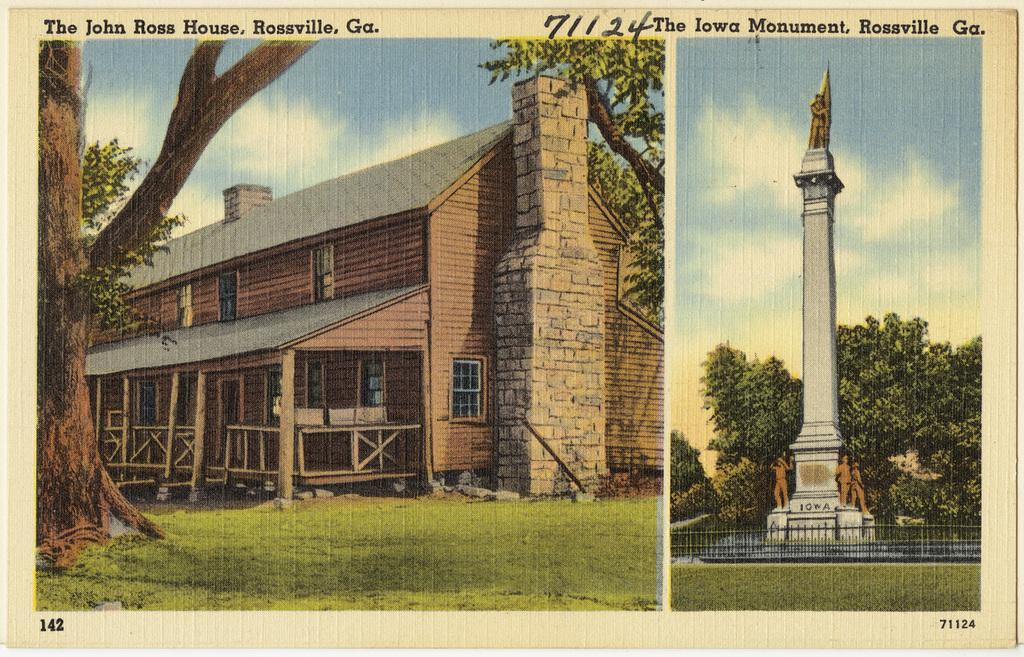What is present in the image that contains both images and text? There is a poster in the image that contains images and text. How many chickens can be seen on the poster in the image? There are no chickens present on the poster in the image. What type of sorting is being done on the poster in the image? There is no sorting activity depicted on the poster in the image. 